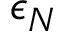Convert formula to latex. <formula><loc_0><loc_0><loc_500><loc_500>\epsilon _ { N }</formula> 